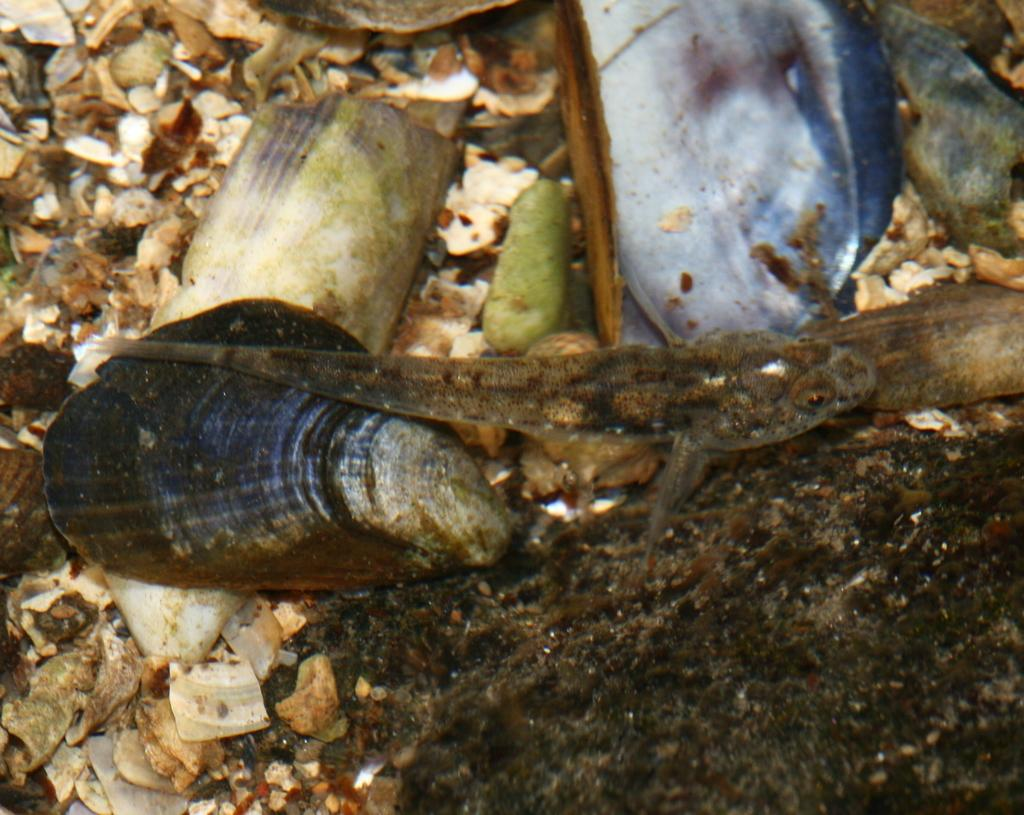What type of animal can be seen in the image? There is a fish in the image. What other objects are present in the water? There are shells and stones in the image. Can you describe the environment in which these objects are located? All of these objects are in the water. What beginner level is required to act in the image? There is no acting or performance in the image, so the concept of a beginner level does not apply. 